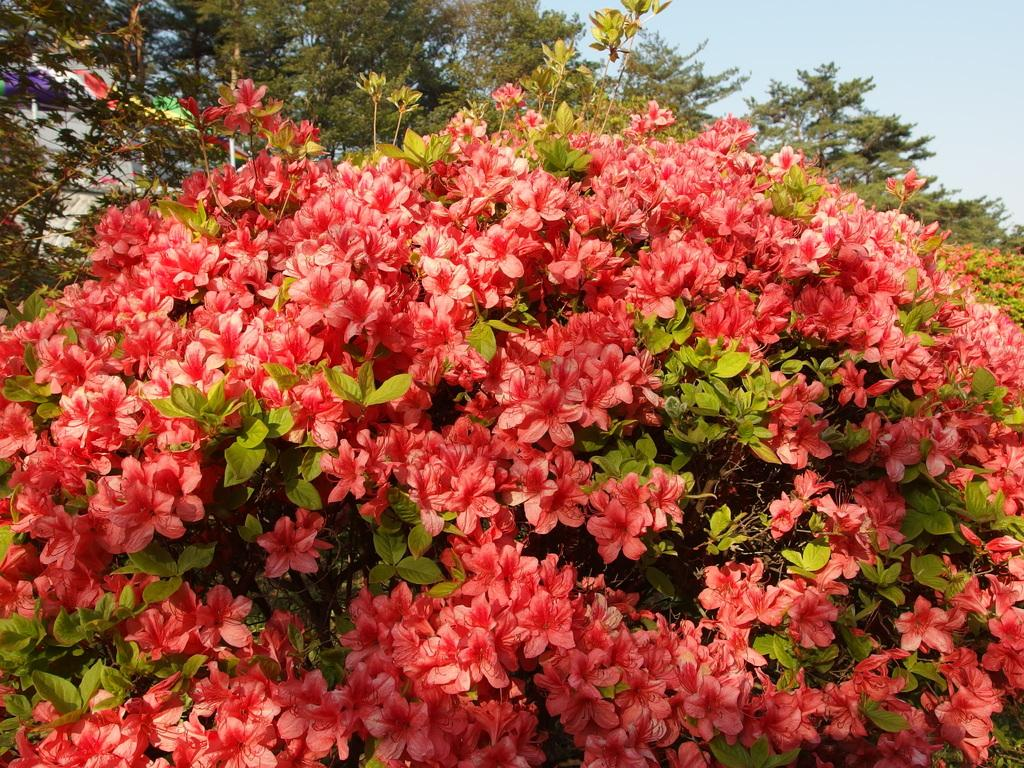What type of vegetation can be seen in the image? There are flowers, leaves, and stems visible in the image. What can be seen in the background of the image? There are trees, plants, and the sky visible in the background of the image. What type of meat can be seen hanging from the trees in the image? There is no meat present in the image; it features flowers, leaves, stems, trees, plants, and the sky. 